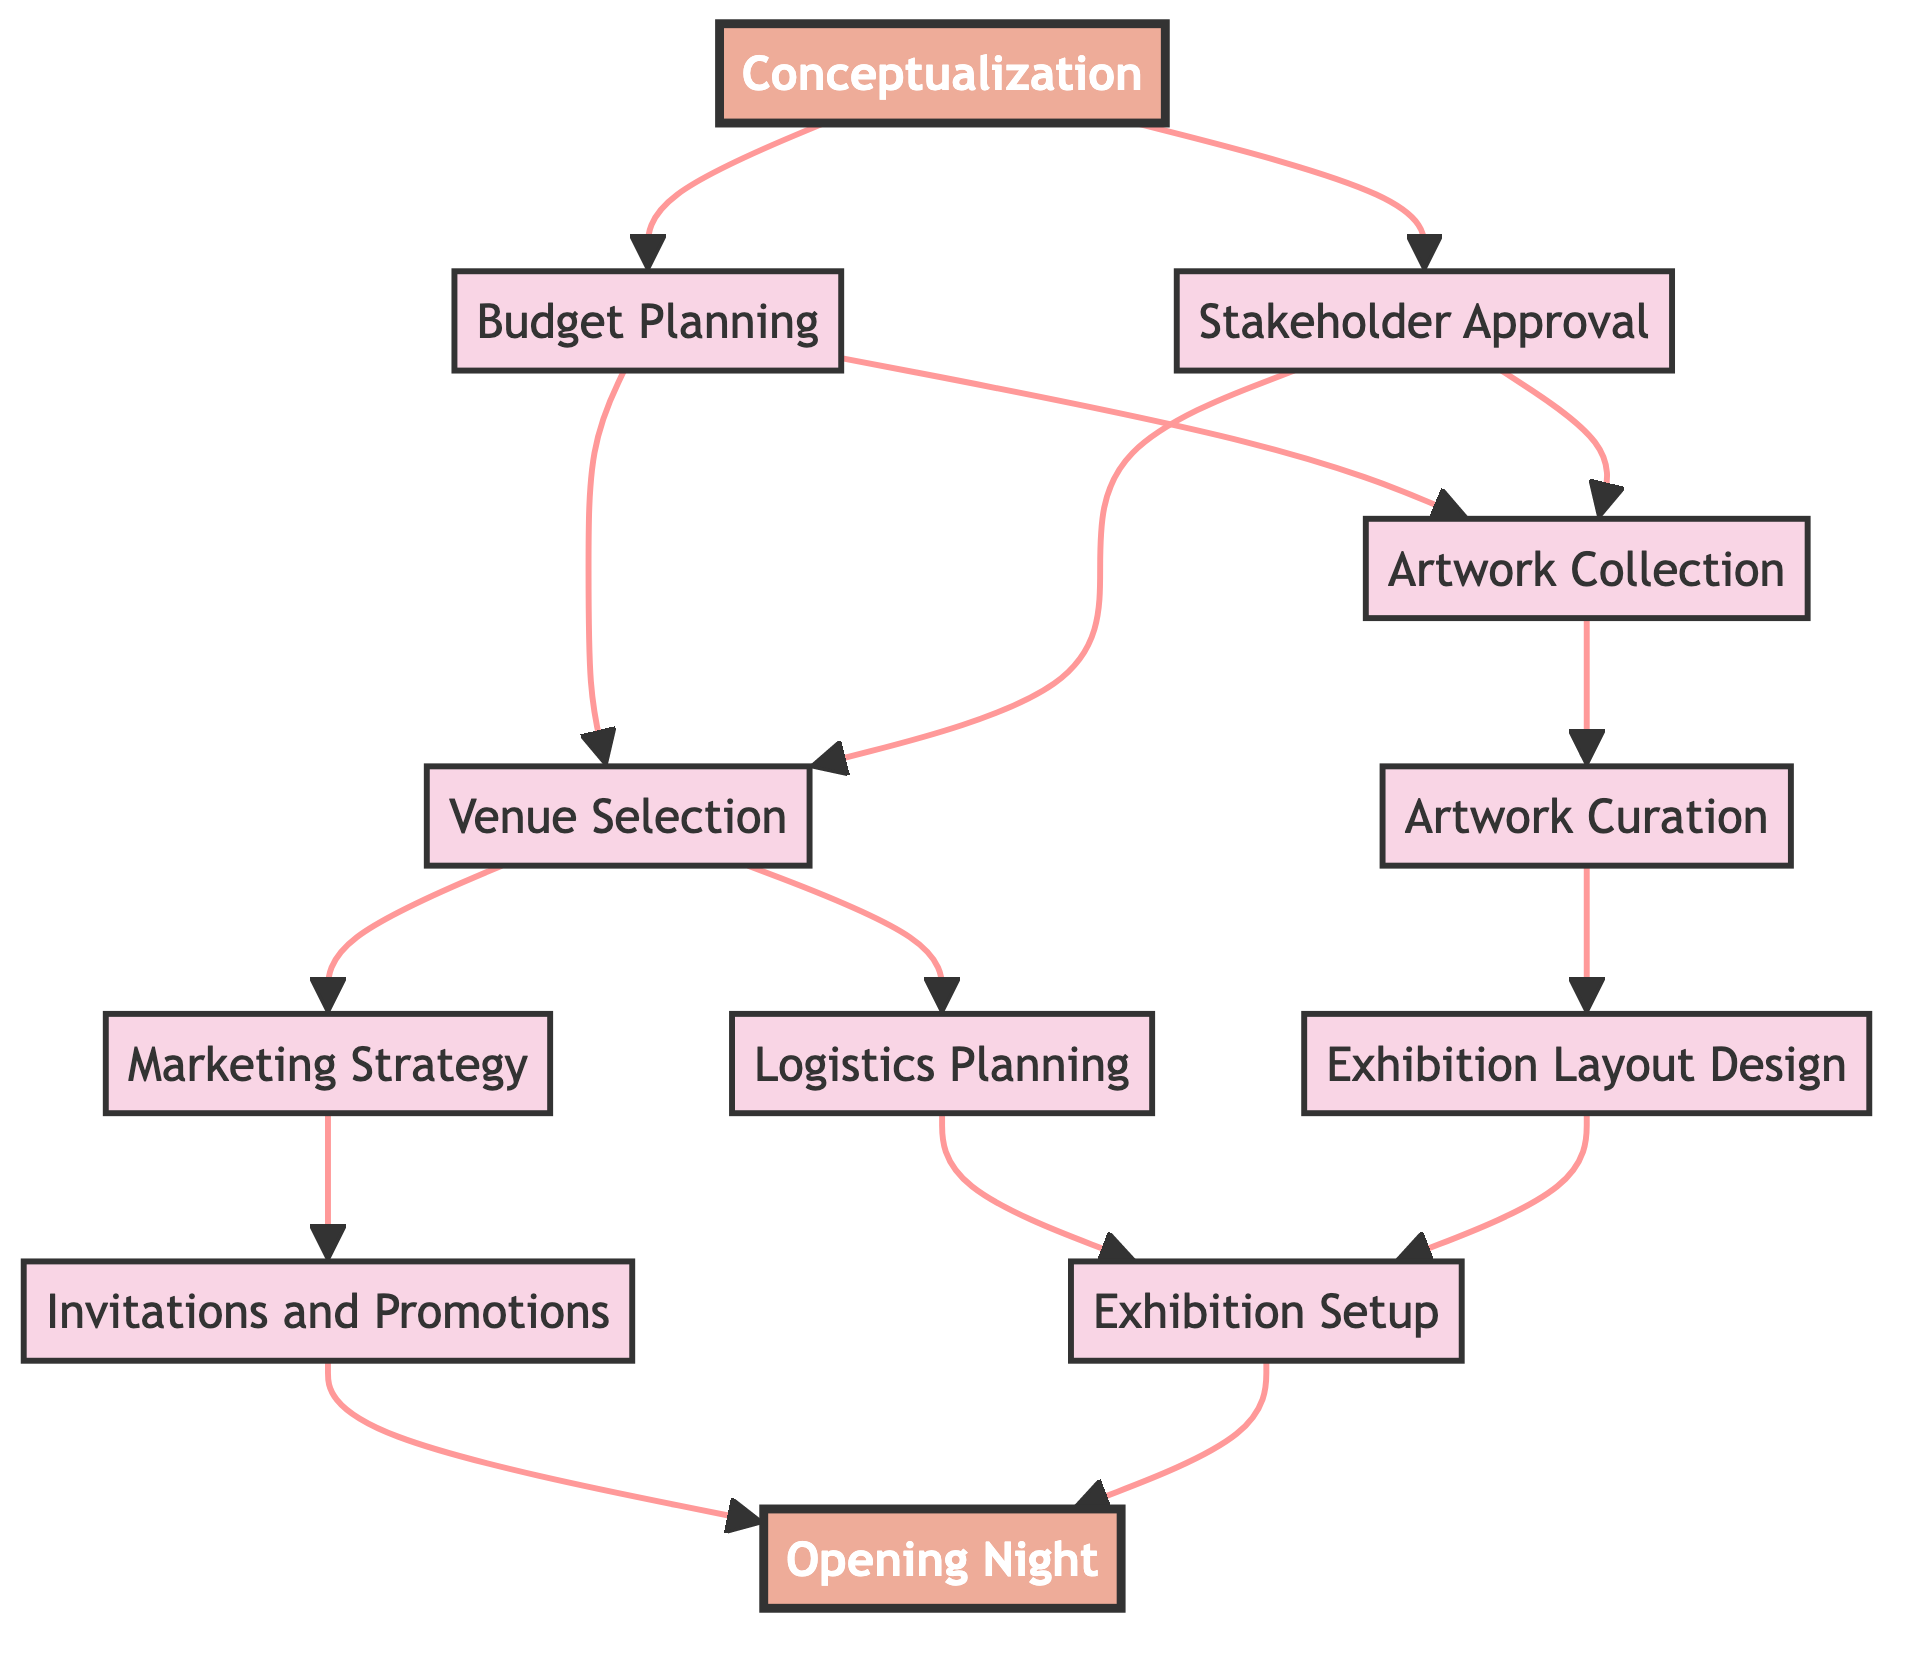What is the first step in organizing the art exhibition? The first step labeled in the diagram is "Conceptualization." It is the starting point from which all other steps flow.
Answer: Conceptualization How many steps are there in total? There are 12 steps shown in the diagram, each represented by a node that outlines various tasks leading to the exhibition's opening night.
Answer: 12 Which step leads to "Artwork Curation"? "Artwork Collection" is the step that directly connects to "Artwork Curation," as indicated by the directed edge from one to the other.
Answer: Artwork Collection What is directly connected to "Logistics Planning"? "Exhibition Setup" is the direct connection following "Logistics Planning," showing that logistics is essential for the setup phase.
Answer: Exhibition Setup What are the two steps that follow "Budget Planning"? The two steps that follow "Budget Planning" are "Venue Selection" and "Artwork Collection," as they both are connected by directed edges from "Budget Planning."
Answer: Venue Selection, Artwork Collection How many steps are necessary to reach "Opening Night" from "Conceptualization"? To reach "Opening Night" from "Conceptualization," it requires moving through 6 steps: Conceptualization -> Budget Planning -> (Venue Selection or Artwork Collection) -> (Logistics Planning or Artwork Curation) -> Exhibition Setup -> Opening Night.
Answer: 6 Which steps lead to "Exhibition Setup"? "Logistics Planning" and "Exhibition Layout Design" lead to "Exhibition Setup." Each of these steps connects directly to it, showing the setup phase's dependency on both logistics and design aspects.
Answer: Logistics Planning, Exhibition Layout Design What is the last step of the process? The last step of the process, as shown in the diagram, is "Opening Night," which is the final event of the exhibition organization.
Answer: Opening Night Which node is connected to both "Marketing Strategy" and "Logistics Planning"? "Venue Selection" is connected to both "Marketing Strategy" and "Logistics Planning," indicating it is a prerequisite for advancing to these activities.
Answer: Venue Selection 